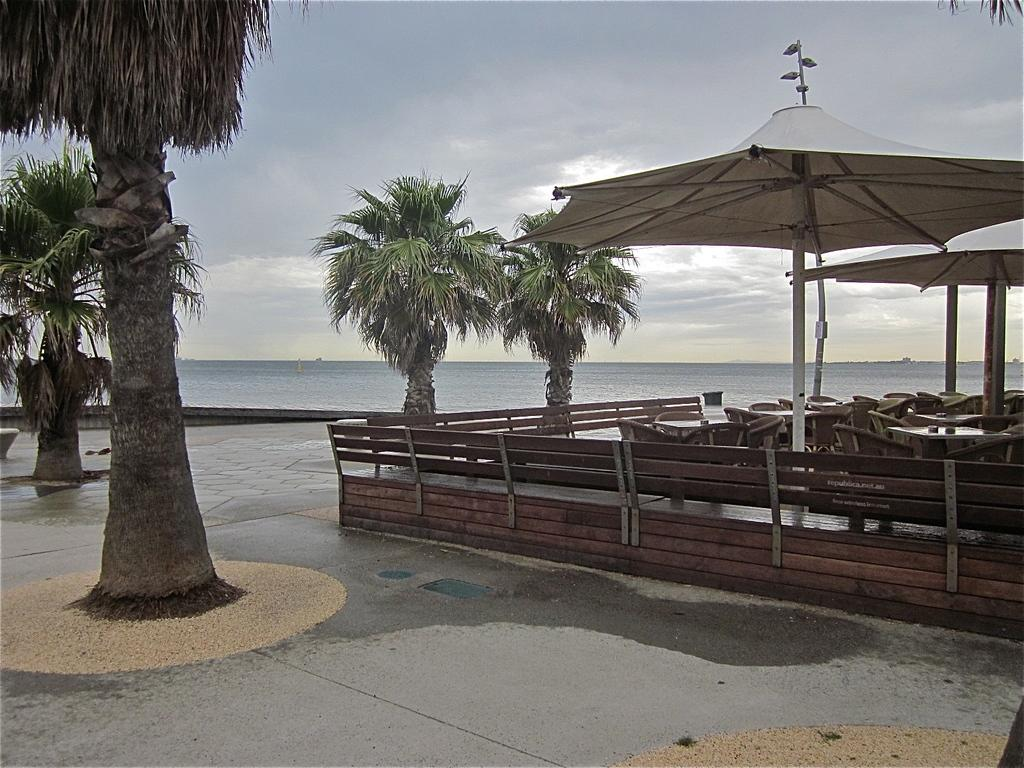What type of natural vegetation can be seen in the image? There are trees in the image. What body of water is visible in the image? The sea is visible in the image. What type of outdoor furniture is present on the right side of the image? There are patio umbrellas, tables, and chairs visible on the right side of the image. What type of barrier is present on the right side of the image? There is a wooden fence on the right side of the image. What is visible in the background of the image? The sky is visible in the background of the image. What type of silverware is being used to eat the food in the image? There is no food or silverware present in the image. What day of the week is depicted in the image? The image does not depict a specific day of the week. 